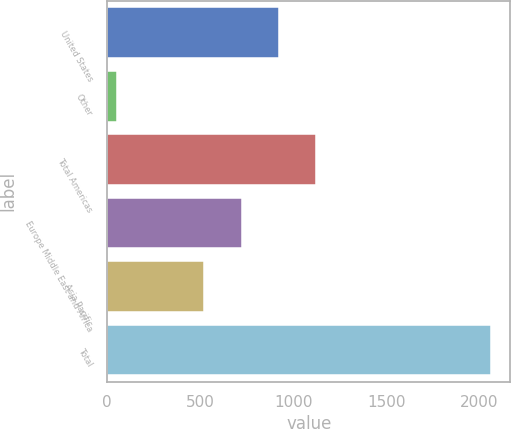<chart> <loc_0><loc_0><loc_500><loc_500><bar_chart><fcel>United States<fcel>Other<fcel>Total Americas<fcel>Europe Middle East and Africa<fcel>Asia Pacific<fcel>Total<nl><fcel>923.02<fcel>53.9<fcel>1124.03<fcel>722.01<fcel>521<fcel>2064<nl></chart> 